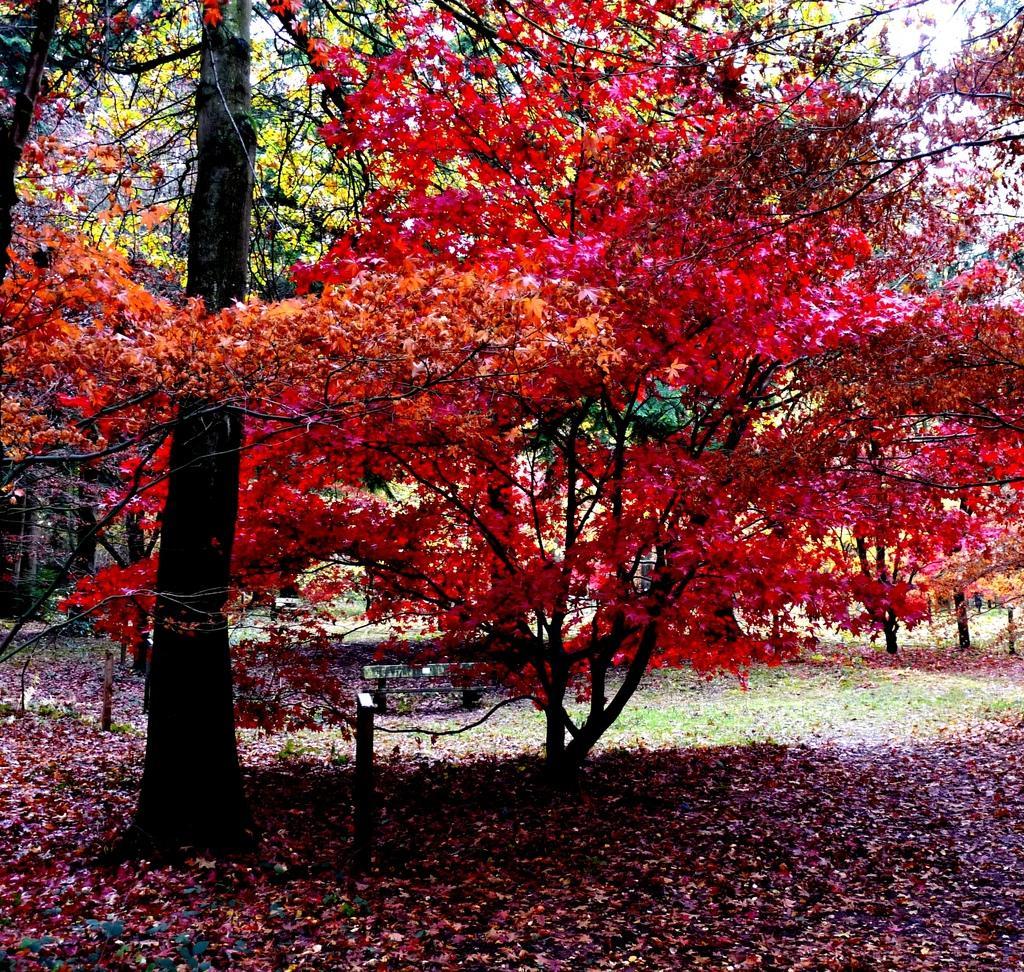In one or two sentences, can you explain what this image depicts? In this image there are many trees. This is a bench. On the ground there are dried leaves, grasses. 